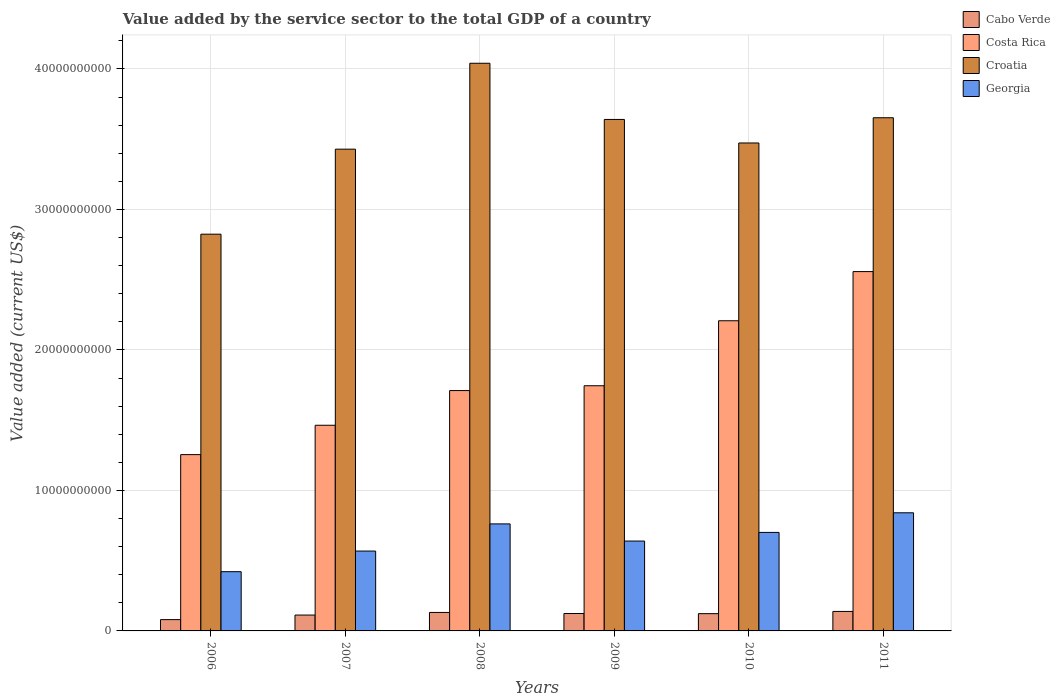How many groups of bars are there?
Provide a succinct answer. 6. Are the number of bars per tick equal to the number of legend labels?
Keep it short and to the point. Yes. Are the number of bars on each tick of the X-axis equal?
Provide a succinct answer. Yes. How many bars are there on the 3rd tick from the left?
Your response must be concise. 4. How many bars are there on the 5th tick from the right?
Your response must be concise. 4. In how many cases, is the number of bars for a given year not equal to the number of legend labels?
Give a very brief answer. 0. What is the value added by the service sector to the total GDP in Georgia in 2011?
Your response must be concise. 8.41e+09. Across all years, what is the maximum value added by the service sector to the total GDP in Georgia?
Ensure brevity in your answer.  8.41e+09. Across all years, what is the minimum value added by the service sector to the total GDP in Costa Rica?
Make the answer very short. 1.25e+1. In which year was the value added by the service sector to the total GDP in Croatia maximum?
Give a very brief answer. 2008. In which year was the value added by the service sector to the total GDP in Costa Rica minimum?
Your answer should be very brief. 2006. What is the total value added by the service sector to the total GDP in Costa Rica in the graph?
Your response must be concise. 1.09e+11. What is the difference between the value added by the service sector to the total GDP in Costa Rica in 2009 and that in 2010?
Provide a succinct answer. -4.63e+09. What is the difference between the value added by the service sector to the total GDP in Croatia in 2010 and the value added by the service sector to the total GDP in Cabo Verde in 2009?
Provide a short and direct response. 3.35e+1. What is the average value added by the service sector to the total GDP in Georgia per year?
Offer a very short reply. 6.56e+09. In the year 2007, what is the difference between the value added by the service sector to the total GDP in Costa Rica and value added by the service sector to the total GDP in Croatia?
Give a very brief answer. -1.97e+1. In how many years, is the value added by the service sector to the total GDP in Costa Rica greater than 32000000000 US$?
Your response must be concise. 0. What is the ratio of the value added by the service sector to the total GDP in Georgia in 2009 to that in 2011?
Give a very brief answer. 0.76. Is the value added by the service sector to the total GDP in Cabo Verde in 2008 less than that in 2009?
Your answer should be very brief. No. Is the difference between the value added by the service sector to the total GDP in Costa Rica in 2009 and 2011 greater than the difference between the value added by the service sector to the total GDP in Croatia in 2009 and 2011?
Give a very brief answer. No. What is the difference between the highest and the second highest value added by the service sector to the total GDP in Cabo Verde?
Keep it short and to the point. 7.23e+07. What is the difference between the highest and the lowest value added by the service sector to the total GDP in Cabo Verde?
Provide a succinct answer. 5.83e+08. What does the 1st bar from the left in 2006 represents?
Your answer should be very brief. Cabo Verde. What does the 4th bar from the right in 2010 represents?
Your answer should be compact. Cabo Verde. How many bars are there?
Make the answer very short. 24. How many years are there in the graph?
Provide a succinct answer. 6. Are the values on the major ticks of Y-axis written in scientific E-notation?
Offer a very short reply. No. Does the graph contain any zero values?
Ensure brevity in your answer.  No. Where does the legend appear in the graph?
Make the answer very short. Top right. How many legend labels are there?
Your answer should be very brief. 4. What is the title of the graph?
Your answer should be very brief. Value added by the service sector to the total GDP of a country. What is the label or title of the Y-axis?
Offer a very short reply. Value added (current US$). What is the Value added (current US$) in Cabo Verde in 2006?
Provide a succinct answer. 8.04e+08. What is the Value added (current US$) of Costa Rica in 2006?
Keep it short and to the point. 1.25e+1. What is the Value added (current US$) of Croatia in 2006?
Make the answer very short. 2.82e+1. What is the Value added (current US$) of Georgia in 2006?
Provide a short and direct response. 4.22e+09. What is the Value added (current US$) of Cabo Verde in 2007?
Offer a terse response. 1.13e+09. What is the Value added (current US$) in Costa Rica in 2007?
Ensure brevity in your answer.  1.46e+1. What is the Value added (current US$) in Croatia in 2007?
Offer a terse response. 3.43e+1. What is the Value added (current US$) of Georgia in 2007?
Ensure brevity in your answer.  5.68e+09. What is the Value added (current US$) in Cabo Verde in 2008?
Give a very brief answer. 1.31e+09. What is the Value added (current US$) in Costa Rica in 2008?
Make the answer very short. 1.71e+1. What is the Value added (current US$) in Croatia in 2008?
Give a very brief answer. 4.04e+1. What is the Value added (current US$) of Georgia in 2008?
Keep it short and to the point. 7.62e+09. What is the Value added (current US$) of Cabo Verde in 2009?
Provide a short and direct response. 1.24e+09. What is the Value added (current US$) of Costa Rica in 2009?
Keep it short and to the point. 1.75e+1. What is the Value added (current US$) in Croatia in 2009?
Provide a short and direct response. 3.64e+1. What is the Value added (current US$) of Georgia in 2009?
Offer a very short reply. 6.40e+09. What is the Value added (current US$) of Cabo Verde in 2010?
Your answer should be very brief. 1.23e+09. What is the Value added (current US$) of Costa Rica in 2010?
Make the answer very short. 2.21e+1. What is the Value added (current US$) of Croatia in 2010?
Your answer should be very brief. 3.47e+1. What is the Value added (current US$) of Georgia in 2010?
Provide a short and direct response. 7.01e+09. What is the Value added (current US$) of Cabo Verde in 2011?
Offer a very short reply. 1.39e+09. What is the Value added (current US$) of Costa Rica in 2011?
Keep it short and to the point. 2.56e+1. What is the Value added (current US$) of Croatia in 2011?
Ensure brevity in your answer.  3.65e+1. What is the Value added (current US$) of Georgia in 2011?
Your response must be concise. 8.41e+09. Across all years, what is the maximum Value added (current US$) of Cabo Verde?
Keep it short and to the point. 1.39e+09. Across all years, what is the maximum Value added (current US$) of Costa Rica?
Ensure brevity in your answer.  2.56e+1. Across all years, what is the maximum Value added (current US$) of Croatia?
Your answer should be compact. 4.04e+1. Across all years, what is the maximum Value added (current US$) in Georgia?
Offer a terse response. 8.41e+09. Across all years, what is the minimum Value added (current US$) in Cabo Verde?
Ensure brevity in your answer.  8.04e+08. Across all years, what is the minimum Value added (current US$) of Costa Rica?
Keep it short and to the point. 1.25e+1. Across all years, what is the minimum Value added (current US$) of Croatia?
Provide a succinct answer. 2.82e+1. Across all years, what is the minimum Value added (current US$) in Georgia?
Give a very brief answer. 4.22e+09. What is the total Value added (current US$) in Cabo Verde in the graph?
Ensure brevity in your answer.  7.10e+09. What is the total Value added (current US$) in Costa Rica in the graph?
Keep it short and to the point. 1.09e+11. What is the total Value added (current US$) of Croatia in the graph?
Give a very brief answer. 2.11e+11. What is the total Value added (current US$) of Georgia in the graph?
Offer a very short reply. 3.93e+1. What is the difference between the Value added (current US$) in Cabo Verde in 2006 and that in 2007?
Your answer should be very brief. -3.25e+08. What is the difference between the Value added (current US$) in Costa Rica in 2006 and that in 2007?
Provide a short and direct response. -2.09e+09. What is the difference between the Value added (current US$) in Croatia in 2006 and that in 2007?
Offer a very short reply. -6.05e+09. What is the difference between the Value added (current US$) of Georgia in 2006 and that in 2007?
Provide a succinct answer. -1.47e+09. What is the difference between the Value added (current US$) in Cabo Verde in 2006 and that in 2008?
Ensure brevity in your answer.  -5.11e+08. What is the difference between the Value added (current US$) of Costa Rica in 2006 and that in 2008?
Your response must be concise. -4.56e+09. What is the difference between the Value added (current US$) in Croatia in 2006 and that in 2008?
Ensure brevity in your answer.  -1.22e+1. What is the difference between the Value added (current US$) of Georgia in 2006 and that in 2008?
Provide a short and direct response. -3.40e+09. What is the difference between the Value added (current US$) in Cabo Verde in 2006 and that in 2009?
Your response must be concise. -4.35e+08. What is the difference between the Value added (current US$) of Costa Rica in 2006 and that in 2009?
Provide a short and direct response. -4.90e+09. What is the difference between the Value added (current US$) of Croatia in 2006 and that in 2009?
Keep it short and to the point. -8.17e+09. What is the difference between the Value added (current US$) in Georgia in 2006 and that in 2009?
Keep it short and to the point. -2.18e+09. What is the difference between the Value added (current US$) of Cabo Verde in 2006 and that in 2010?
Make the answer very short. -4.25e+08. What is the difference between the Value added (current US$) in Costa Rica in 2006 and that in 2010?
Keep it short and to the point. -9.53e+09. What is the difference between the Value added (current US$) in Croatia in 2006 and that in 2010?
Keep it short and to the point. -6.49e+09. What is the difference between the Value added (current US$) of Georgia in 2006 and that in 2010?
Your answer should be very brief. -2.79e+09. What is the difference between the Value added (current US$) of Cabo Verde in 2006 and that in 2011?
Provide a succinct answer. -5.83e+08. What is the difference between the Value added (current US$) in Costa Rica in 2006 and that in 2011?
Provide a short and direct response. -1.30e+1. What is the difference between the Value added (current US$) of Croatia in 2006 and that in 2011?
Offer a terse response. -8.29e+09. What is the difference between the Value added (current US$) in Georgia in 2006 and that in 2011?
Make the answer very short. -4.19e+09. What is the difference between the Value added (current US$) in Cabo Verde in 2007 and that in 2008?
Keep it short and to the point. -1.86e+08. What is the difference between the Value added (current US$) of Costa Rica in 2007 and that in 2008?
Give a very brief answer. -2.47e+09. What is the difference between the Value added (current US$) of Croatia in 2007 and that in 2008?
Your response must be concise. -6.11e+09. What is the difference between the Value added (current US$) of Georgia in 2007 and that in 2008?
Keep it short and to the point. -1.93e+09. What is the difference between the Value added (current US$) of Cabo Verde in 2007 and that in 2009?
Give a very brief answer. -1.11e+08. What is the difference between the Value added (current US$) in Costa Rica in 2007 and that in 2009?
Offer a terse response. -2.81e+09. What is the difference between the Value added (current US$) of Croatia in 2007 and that in 2009?
Provide a short and direct response. -2.12e+09. What is the difference between the Value added (current US$) in Georgia in 2007 and that in 2009?
Keep it short and to the point. -7.12e+08. What is the difference between the Value added (current US$) in Cabo Verde in 2007 and that in 2010?
Give a very brief answer. -1.00e+08. What is the difference between the Value added (current US$) in Costa Rica in 2007 and that in 2010?
Your answer should be compact. -7.44e+09. What is the difference between the Value added (current US$) in Croatia in 2007 and that in 2010?
Make the answer very short. -4.40e+08. What is the difference between the Value added (current US$) in Georgia in 2007 and that in 2010?
Give a very brief answer. -1.33e+09. What is the difference between the Value added (current US$) of Cabo Verde in 2007 and that in 2011?
Make the answer very short. -2.58e+08. What is the difference between the Value added (current US$) of Costa Rica in 2007 and that in 2011?
Give a very brief answer. -1.09e+1. What is the difference between the Value added (current US$) in Croatia in 2007 and that in 2011?
Your answer should be very brief. -2.24e+09. What is the difference between the Value added (current US$) of Georgia in 2007 and that in 2011?
Ensure brevity in your answer.  -2.72e+09. What is the difference between the Value added (current US$) in Cabo Verde in 2008 and that in 2009?
Your answer should be compact. 7.53e+07. What is the difference between the Value added (current US$) in Costa Rica in 2008 and that in 2009?
Ensure brevity in your answer.  -3.43e+08. What is the difference between the Value added (current US$) of Croatia in 2008 and that in 2009?
Your response must be concise. 4.00e+09. What is the difference between the Value added (current US$) in Georgia in 2008 and that in 2009?
Provide a succinct answer. 1.22e+09. What is the difference between the Value added (current US$) in Cabo Verde in 2008 and that in 2010?
Your answer should be very brief. 8.57e+07. What is the difference between the Value added (current US$) of Costa Rica in 2008 and that in 2010?
Give a very brief answer. -4.97e+09. What is the difference between the Value added (current US$) in Croatia in 2008 and that in 2010?
Offer a terse response. 5.67e+09. What is the difference between the Value added (current US$) of Georgia in 2008 and that in 2010?
Give a very brief answer. 6.06e+08. What is the difference between the Value added (current US$) in Cabo Verde in 2008 and that in 2011?
Your response must be concise. -7.23e+07. What is the difference between the Value added (current US$) in Costa Rica in 2008 and that in 2011?
Provide a short and direct response. -8.47e+09. What is the difference between the Value added (current US$) of Croatia in 2008 and that in 2011?
Provide a succinct answer. 3.88e+09. What is the difference between the Value added (current US$) in Georgia in 2008 and that in 2011?
Make the answer very short. -7.90e+08. What is the difference between the Value added (current US$) in Cabo Verde in 2009 and that in 2010?
Give a very brief answer. 1.04e+07. What is the difference between the Value added (current US$) in Costa Rica in 2009 and that in 2010?
Offer a terse response. -4.63e+09. What is the difference between the Value added (current US$) in Croatia in 2009 and that in 2010?
Offer a terse response. 1.67e+09. What is the difference between the Value added (current US$) of Georgia in 2009 and that in 2010?
Make the answer very short. -6.16e+08. What is the difference between the Value added (current US$) in Cabo Verde in 2009 and that in 2011?
Your response must be concise. -1.48e+08. What is the difference between the Value added (current US$) in Costa Rica in 2009 and that in 2011?
Your answer should be very brief. -8.13e+09. What is the difference between the Value added (current US$) in Croatia in 2009 and that in 2011?
Provide a short and direct response. -1.21e+08. What is the difference between the Value added (current US$) of Georgia in 2009 and that in 2011?
Provide a short and direct response. -2.01e+09. What is the difference between the Value added (current US$) of Cabo Verde in 2010 and that in 2011?
Provide a short and direct response. -1.58e+08. What is the difference between the Value added (current US$) in Costa Rica in 2010 and that in 2011?
Offer a terse response. -3.50e+09. What is the difference between the Value added (current US$) of Croatia in 2010 and that in 2011?
Provide a succinct answer. -1.80e+09. What is the difference between the Value added (current US$) in Georgia in 2010 and that in 2011?
Offer a very short reply. -1.40e+09. What is the difference between the Value added (current US$) of Cabo Verde in 2006 and the Value added (current US$) of Costa Rica in 2007?
Offer a terse response. -1.38e+1. What is the difference between the Value added (current US$) in Cabo Verde in 2006 and the Value added (current US$) in Croatia in 2007?
Ensure brevity in your answer.  -3.35e+1. What is the difference between the Value added (current US$) in Cabo Verde in 2006 and the Value added (current US$) in Georgia in 2007?
Your answer should be compact. -4.88e+09. What is the difference between the Value added (current US$) of Costa Rica in 2006 and the Value added (current US$) of Croatia in 2007?
Provide a succinct answer. -2.17e+1. What is the difference between the Value added (current US$) in Costa Rica in 2006 and the Value added (current US$) in Georgia in 2007?
Make the answer very short. 6.86e+09. What is the difference between the Value added (current US$) of Croatia in 2006 and the Value added (current US$) of Georgia in 2007?
Make the answer very short. 2.26e+1. What is the difference between the Value added (current US$) in Cabo Verde in 2006 and the Value added (current US$) in Costa Rica in 2008?
Your answer should be very brief. -1.63e+1. What is the difference between the Value added (current US$) in Cabo Verde in 2006 and the Value added (current US$) in Croatia in 2008?
Provide a succinct answer. -3.96e+1. What is the difference between the Value added (current US$) of Cabo Verde in 2006 and the Value added (current US$) of Georgia in 2008?
Keep it short and to the point. -6.81e+09. What is the difference between the Value added (current US$) of Costa Rica in 2006 and the Value added (current US$) of Croatia in 2008?
Your answer should be very brief. -2.79e+1. What is the difference between the Value added (current US$) in Costa Rica in 2006 and the Value added (current US$) in Georgia in 2008?
Offer a very short reply. 4.93e+09. What is the difference between the Value added (current US$) of Croatia in 2006 and the Value added (current US$) of Georgia in 2008?
Give a very brief answer. 2.06e+1. What is the difference between the Value added (current US$) of Cabo Verde in 2006 and the Value added (current US$) of Costa Rica in 2009?
Your response must be concise. -1.66e+1. What is the difference between the Value added (current US$) of Cabo Verde in 2006 and the Value added (current US$) of Croatia in 2009?
Provide a succinct answer. -3.56e+1. What is the difference between the Value added (current US$) in Cabo Verde in 2006 and the Value added (current US$) in Georgia in 2009?
Ensure brevity in your answer.  -5.59e+09. What is the difference between the Value added (current US$) of Costa Rica in 2006 and the Value added (current US$) of Croatia in 2009?
Your response must be concise. -2.39e+1. What is the difference between the Value added (current US$) in Costa Rica in 2006 and the Value added (current US$) in Georgia in 2009?
Keep it short and to the point. 6.15e+09. What is the difference between the Value added (current US$) in Croatia in 2006 and the Value added (current US$) in Georgia in 2009?
Ensure brevity in your answer.  2.18e+1. What is the difference between the Value added (current US$) of Cabo Verde in 2006 and the Value added (current US$) of Costa Rica in 2010?
Give a very brief answer. -2.13e+1. What is the difference between the Value added (current US$) of Cabo Verde in 2006 and the Value added (current US$) of Croatia in 2010?
Give a very brief answer. -3.39e+1. What is the difference between the Value added (current US$) of Cabo Verde in 2006 and the Value added (current US$) of Georgia in 2010?
Offer a very short reply. -6.21e+09. What is the difference between the Value added (current US$) in Costa Rica in 2006 and the Value added (current US$) in Croatia in 2010?
Your response must be concise. -2.22e+1. What is the difference between the Value added (current US$) in Costa Rica in 2006 and the Value added (current US$) in Georgia in 2010?
Your answer should be compact. 5.54e+09. What is the difference between the Value added (current US$) in Croatia in 2006 and the Value added (current US$) in Georgia in 2010?
Offer a very short reply. 2.12e+1. What is the difference between the Value added (current US$) in Cabo Verde in 2006 and the Value added (current US$) in Costa Rica in 2011?
Offer a terse response. -2.48e+1. What is the difference between the Value added (current US$) of Cabo Verde in 2006 and the Value added (current US$) of Croatia in 2011?
Provide a short and direct response. -3.57e+1. What is the difference between the Value added (current US$) of Cabo Verde in 2006 and the Value added (current US$) of Georgia in 2011?
Your answer should be very brief. -7.60e+09. What is the difference between the Value added (current US$) in Costa Rica in 2006 and the Value added (current US$) in Croatia in 2011?
Provide a short and direct response. -2.40e+1. What is the difference between the Value added (current US$) of Costa Rica in 2006 and the Value added (current US$) of Georgia in 2011?
Offer a terse response. 4.14e+09. What is the difference between the Value added (current US$) in Croatia in 2006 and the Value added (current US$) in Georgia in 2011?
Your answer should be compact. 1.98e+1. What is the difference between the Value added (current US$) of Cabo Verde in 2007 and the Value added (current US$) of Costa Rica in 2008?
Your response must be concise. -1.60e+1. What is the difference between the Value added (current US$) of Cabo Verde in 2007 and the Value added (current US$) of Croatia in 2008?
Offer a very short reply. -3.93e+1. What is the difference between the Value added (current US$) of Cabo Verde in 2007 and the Value added (current US$) of Georgia in 2008?
Offer a terse response. -6.49e+09. What is the difference between the Value added (current US$) of Costa Rica in 2007 and the Value added (current US$) of Croatia in 2008?
Your answer should be very brief. -2.58e+1. What is the difference between the Value added (current US$) in Costa Rica in 2007 and the Value added (current US$) in Georgia in 2008?
Give a very brief answer. 7.02e+09. What is the difference between the Value added (current US$) in Croatia in 2007 and the Value added (current US$) in Georgia in 2008?
Your answer should be very brief. 2.67e+1. What is the difference between the Value added (current US$) in Cabo Verde in 2007 and the Value added (current US$) in Costa Rica in 2009?
Offer a terse response. -1.63e+1. What is the difference between the Value added (current US$) in Cabo Verde in 2007 and the Value added (current US$) in Croatia in 2009?
Give a very brief answer. -3.53e+1. What is the difference between the Value added (current US$) in Cabo Verde in 2007 and the Value added (current US$) in Georgia in 2009?
Keep it short and to the point. -5.27e+09. What is the difference between the Value added (current US$) in Costa Rica in 2007 and the Value added (current US$) in Croatia in 2009?
Offer a terse response. -2.18e+1. What is the difference between the Value added (current US$) in Costa Rica in 2007 and the Value added (current US$) in Georgia in 2009?
Provide a short and direct response. 8.24e+09. What is the difference between the Value added (current US$) of Croatia in 2007 and the Value added (current US$) of Georgia in 2009?
Offer a terse response. 2.79e+1. What is the difference between the Value added (current US$) in Cabo Verde in 2007 and the Value added (current US$) in Costa Rica in 2010?
Offer a very short reply. -2.09e+1. What is the difference between the Value added (current US$) of Cabo Verde in 2007 and the Value added (current US$) of Croatia in 2010?
Ensure brevity in your answer.  -3.36e+1. What is the difference between the Value added (current US$) in Cabo Verde in 2007 and the Value added (current US$) in Georgia in 2010?
Your answer should be compact. -5.88e+09. What is the difference between the Value added (current US$) in Costa Rica in 2007 and the Value added (current US$) in Croatia in 2010?
Give a very brief answer. -2.01e+1. What is the difference between the Value added (current US$) of Costa Rica in 2007 and the Value added (current US$) of Georgia in 2010?
Ensure brevity in your answer.  7.63e+09. What is the difference between the Value added (current US$) in Croatia in 2007 and the Value added (current US$) in Georgia in 2010?
Make the answer very short. 2.73e+1. What is the difference between the Value added (current US$) in Cabo Verde in 2007 and the Value added (current US$) in Costa Rica in 2011?
Provide a short and direct response. -2.44e+1. What is the difference between the Value added (current US$) of Cabo Verde in 2007 and the Value added (current US$) of Croatia in 2011?
Provide a succinct answer. -3.54e+1. What is the difference between the Value added (current US$) in Cabo Verde in 2007 and the Value added (current US$) in Georgia in 2011?
Provide a succinct answer. -7.28e+09. What is the difference between the Value added (current US$) in Costa Rica in 2007 and the Value added (current US$) in Croatia in 2011?
Offer a very short reply. -2.19e+1. What is the difference between the Value added (current US$) in Costa Rica in 2007 and the Value added (current US$) in Georgia in 2011?
Offer a terse response. 6.23e+09. What is the difference between the Value added (current US$) in Croatia in 2007 and the Value added (current US$) in Georgia in 2011?
Give a very brief answer. 2.59e+1. What is the difference between the Value added (current US$) in Cabo Verde in 2008 and the Value added (current US$) in Costa Rica in 2009?
Your answer should be compact. -1.61e+1. What is the difference between the Value added (current US$) of Cabo Verde in 2008 and the Value added (current US$) of Croatia in 2009?
Your answer should be compact. -3.51e+1. What is the difference between the Value added (current US$) of Cabo Verde in 2008 and the Value added (current US$) of Georgia in 2009?
Provide a succinct answer. -5.08e+09. What is the difference between the Value added (current US$) of Costa Rica in 2008 and the Value added (current US$) of Croatia in 2009?
Your response must be concise. -1.93e+1. What is the difference between the Value added (current US$) in Costa Rica in 2008 and the Value added (current US$) in Georgia in 2009?
Give a very brief answer. 1.07e+1. What is the difference between the Value added (current US$) of Croatia in 2008 and the Value added (current US$) of Georgia in 2009?
Your answer should be very brief. 3.40e+1. What is the difference between the Value added (current US$) of Cabo Verde in 2008 and the Value added (current US$) of Costa Rica in 2010?
Your response must be concise. -2.08e+1. What is the difference between the Value added (current US$) of Cabo Verde in 2008 and the Value added (current US$) of Croatia in 2010?
Your answer should be very brief. -3.34e+1. What is the difference between the Value added (current US$) of Cabo Verde in 2008 and the Value added (current US$) of Georgia in 2010?
Provide a short and direct response. -5.70e+09. What is the difference between the Value added (current US$) of Costa Rica in 2008 and the Value added (current US$) of Croatia in 2010?
Make the answer very short. -1.76e+1. What is the difference between the Value added (current US$) of Costa Rica in 2008 and the Value added (current US$) of Georgia in 2010?
Give a very brief answer. 1.01e+1. What is the difference between the Value added (current US$) in Croatia in 2008 and the Value added (current US$) in Georgia in 2010?
Offer a very short reply. 3.34e+1. What is the difference between the Value added (current US$) of Cabo Verde in 2008 and the Value added (current US$) of Costa Rica in 2011?
Keep it short and to the point. -2.43e+1. What is the difference between the Value added (current US$) of Cabo Verde in 2008 and the Value added (current US$) of Croatia in 2011?
Offer a terse response. -3.52e+1. What is the difference between the Value added (current US$) of Cabo Verde in 2008 and the Value added (current US$) of Georgia in 2011?
Make the answer very short. -7.09e+09. What is the difference between the Value added (current US$) of Costa Rica in 2008 and the Value added (current US$) of Croatia in 2011?
Offer a terse response. -1.94e+1. What is the difference between the Value added (current US$) of Costa Rica in 2008 and the Value added (current US$) of Georgia in 2011?
Keep it short and to the point. 8.70e+09. What is the difference between the Value added (current US$) of Croatia in 2008 and the Value added (current US$) of Georgia in 2011?
Provide a short and direct response. 3.20e+1. What is the difference between the Value added (current US$) of Cabo Verde in 2009 and the Value added (current US$) of Costa Rica in 2010?
Make the answer very short. -2.08e+1. What is the difference between the Value added (current US$) in Cabo Verde in 2009 and the Value added (current US$) in Croatia in 2010?
Offer a very short reply. -3.35e+1. What is the difference between the Value added (current US$) of Cabo Verde in 2009 and the Value added (current US$) of Georgia in 2010?
Your response must be concise. -5.77e+09. What is the difference between the Value added (current US$) in Costa Rica in 2009 and the Value added (current US$) in Croatia in 2010?
Offer a very short reply. -1.73e+1. What is the difference between the Value added (current US$) in Costa Rica in 2009 and the Value added (current US$) in Georgia in 2010?
Your response must be concise. 1.04e+1. What is the difference between the Value added (current US$) in Croatia in 2009 and the Value added (current US$) in Georgia in 2010?
Provide a succinct answer. 2.94e+1. What is the difference between the Value added (current US$) in Cabo Verde in 2009 and the Value added (current US$) in Costa Rica in 2011?
Provide a succinct answer. -2.43e+1. What is the difference between the Value added (current US$) of Cabo Verde in 2009 and the Value added (current US$) of Croatia in 2011?
Provide a short and direct response. -3.53e+1. What is the difference between the Value added (current US$) of Cabo Verde in 2009 and the Value added (current US$) of Georgia in 2011?
Give a very brief answer. -7.17e+09. What is the difference between the Value added (current US$) of Costa Rica in 2009 and the Value added (current US$) of Croatia in 2011?
Your answer should be very brief. -1.91e+1. What is the difference between the Value added (current US$) of Costa Rica in 2009 and the Value added (current US$) of Georgia in 2011?
Your response must be concise. 9.04e+09. What is the difference between the Value added (current US$) in Croatia in 2009 and the Value added (current US$) in Georgia in 2011?
Make the answer very short. 2.80e+1. What is the difference between the Value added (current US$) of Cabo Verde in 2010 and the Value added (current US$) of Costa Rica in 2011?
Give a very brief answer. -2.43e+1. What is the difference between the Value added (current US$) of Cabo Verde in 2010 and the Value added (current US$) of Croatia in 2011?
Keep it short and to the point. -3.53e+1. What is the difference between the Value added (current US$) of Cabo Verde in 2010 and the Value added (current US$) of Georgia in 2011?
Make the answer very short. -7.18e+09. What is the difference between the Value added (current US$) in Costa Rica in 2010 and the Value added (current US$) in Croatia in 2011?
Your answer should be compact. -1.45e+1. What is the difference between the Value added (current US$) of Costa Rica in 2010 and the Value added (current US$) of Georgia in 2011?
Make the answer very short. 1.37e+1. What is the difference between the Value added (current US$) of Croatia in 2010 and the Value added (current US$) of Georgia in 2011?
Offer a very short reply. 2.63e+1. What is the average Value added (current US$) of Cabo Verde per year?
Offer a very short reply. 1.18e+09. What is the average Value added (current US$) of Costa Rica per year?
Your answer should be very brief. 1.82e+1. What is the average Value added (current US$) of Croatia per year?
Your response must be concise. 3.51e+1. What is the average Value added (current US$) in Georgia per year?
Provide a succinct answer. 6.56e+09. In the year 2006, what is the difference between the Value added (current US$) in Cabo Verde and Value added (current US$) in Costa Rica?
Provide a short and direct response. -1.17e+1. In the year 2006, what is the difference between the Value added (current US$) of Cabo Verde and Value added (current US$) of Croatia?
Offer a very short reply. -2.74e+1. In the year 2006, what is the difference between the Value added (current US$) of Cabo Verde and Value added (current US$) of Georgia?
Your answer should be compact. -3.41e+09. In the year 2006, what is the difference between the Value added (current US$) in Costa Rica and Value added (current US$) in Croatia?
Ensure brevity in your answer.  -1.57e+1. In the year 2006, what is the difference between the Value added (current US$) in Costa Rica and Value added (current US$) in Georgia?
Your response must be concise. 8.33e+09. In the year 2006, what is the difference between the Value added (current US$) in Croatia and Value added (current US$) in Georgia?
Your answer should be compact. 2.40e+1. In the year 2007, what is the difference between the Value added (current US$) of Cabo Verde and Value added (current US$) of Costa Rica?
Ensure brevity in your answer.  -1.35e+1. In the year 2007, what is the difference between the Value added (current US$) of Cabo Verde and Value added (current US$) of Croatia?
Give a very brief answer. -3.32e+1. In the year 2007, what is the difference between the Value added (current US$) in Cabo Verde and Value added (current US$) in Georgia?
Keep it short and to the point. -4.56e+09. In the year 2007, what is the difference between the Value added (current US$) in Costa Rica and Value added (current US$) in Croatia?
Offer a terse response. -1.97e+1. In the year 2007, what is the difference between the Value added (current US$) in Costa Rica and Value added (current US$) in Georgia?
Keep it short and to the point. 8.95e+09. In the year 2007, what is the difference between the Value added (current US$) in Croatia and Value added (current US$) in Georgia?
Give a very brief answer. 2.86e+1. In the year 2008, what is the difference between the Value added (current US$) in Cabo Verde and Value added (current US$) in Costa Rica?
Offer a terse response. -1.58e+1. In the year 2008, what is the difference between the Value added (current US$) in Cabo Verde and Value added (current US$) in Croatia?
Provide a succinct answer. -3.91e+1. In the year 2008, what is the difference between the Value added (current US$) of Cabo Verde and Value added (current US$) of Georgia?
Your answer should be compact. -6.30e+09. In the year 2008, what is the difference between the Value added (current US$) in Costa Rica and Value added (current US$) in Croatia?
Your response must be concise. -2.33e+1. In the year 2008, what is the difference between the Value added (current US$) in Costa Rica and Value added (current US$) in Georgia?
Keep it short and to the point. 9.49e+09. In the year 2008, what is the difference between the Value added (current US$) of Croatia and Value added (current US$) of Georgia?
Offer a terse response. 3.28e+1. In the year 2009, what is the difference between the Value added (current US$) of Cabo Verde and Value added (current US$) of Costa Rica?
Your response must be concise. -1.62e+1. In the year 2009, what is the difference between the Value added (current US$) in Cabo Verde and Value added (current US$) in Croatia?
Provide a short and direct response. -3.52e+1. In the year 2009, what is the difference between the Value added (current US$) in Cabo Verde and Value added (current US$) in Georgia?
Provide a short and direct response. -5.16e+09. In the year 2009, what is the difference between the Value added (current US$) in Costa Rica and Value added (current US$) in Croatia?
Offer a very short reply. -1.90e+1. In the year 2009, what is the difference between the Value added (current US$) in Costa Rica and Value added (current US$) in Georgia?
Your response must be concise. 1.11e+1. In the year 2009, what is the difference between the Value added (current US$) of Croatia and Value added (current US$) of Georgia?
Provide a succinct answer. 3.00e+1. In the year 2010, what is the difference between the Value added (current US$) in Cabo Verde and Value added (current US$) in Costa Rica?
Offer a terse response. -2.08e+1. In the year 2010, what is the difference between the Value added (current US$) of Cabo Verde and Value added (current US$) of Croatia?
Your answer should be compact. -3.35e+1. In the year 2010, what is the difference between the Value added (current US$) of Cabo Verde and Value added (current US$) of Georgia?
Make the answer very short. -5.78e+09. In the year 2010, what is the difference between the Value added (current US$) of Costa Rica and Value added (current US$) of Croatia?
Provide a succinct answer. -1.27e+1. In the year 2010, what is the difference between the Value added (current US$) in Costa Rica and Value added (current US$) in Georgia?
Provide a short and direct response. 1.51e+1. In the year 2010, what is the difference between the Value added (current US$) in Croatia and Value added (current US$) in Georgia?
Your answer should be compact. 2.77e+1. In the year 2011, what is the difference between the Value added (current US$) of Cabo Verde and Value added (current US$) of Costa Rica?
Your answer should be compact. -2.42e+1. In the year 2011, what is the difference between the Value added (current US$) of Cabo Verde and Value added (current US$) of Croatia?
Give a very brief answer. -3.51e+1. In the year 2011, what is the difference between the Value added (current US$) in Cabo Verde and Value added (current US$) in Georgia?
Provide a short and direct response. -7.02e+09. In the year 2011, what is the difference between the Value added (current US$) in Costa Rica and Value added (current US$) in Croatia?
Ensure brevity in your answer.  -1.10e+1. In the year 2011, what is the difference between the Value added (current US$) in Costa Rica and Value added (current US$) in Georgia?
Offer a very short reply. 1.72e+1. In the year 2011, what is the difference between the Value added (current US$) in Croatia and Value added (current US$) in Georgia?
Offer a terse response. 2.81e+1. What is the ratio of the Value added (current US$) in Cabo Verde in 2006 to that in 2007?
Your answer should be very brief. 0.71. What is the ratio of the Value added (current US$) in Costa Rica in 2006 to that in 2007?
Give a very brief answer. 0.86. What is the ratio of the Value added (current US$) in Croatia in 2006 to that in 2007?
Give a very brief answer. 0.82. What is the ratio of the Value added (current US$) in Georgia in 2006 to that in 2007?
Give a very brief answer. 0.74. What is the ratio of the Value added (current US$) in Cabo Verde in 2006 to that in 2008?
Offer a terse response. 0.61. What is the ratio of the Value added (current US$) of Costa Rica in 2006 to that in 2008?
Provide a short and direct response. 0.73. What is the ratio of the Value added (current US$) in Croatia in 2006 to that in 2008?
Provide a short and direct response. 0.7. What is the ratio of the Value added (current US$) of Georgia in 2006 to that in 2008?
Your answer should be compact. 0.55. What is the ratio of the Value added (current US$) of Cabo Verde in 2006 to that in 2009?
Give a very brief answer. 0.65. What is the ratio of the Value added (current US$) in Costa Rica in 2006 to that in 2009?
Give a very brief answer. 0.72. What is the ratio of the Value added (current US$) in Croatia in 2006 to that in 2009?
Make the answer very short. 0.78. What is the ratio of the Value added (current US$) in Georgia in 2006 to that in 2009?
Ensure brevity in your answer.  0.66. What is the ratio of the Value added (current US$) in Cabo Verde in 2006 to that in 2010?
Your response must be concise. 0.65. What is the ratio of the Value added (current US$) of Costa Rica in 2006 to that in 2010?
Ensure brevity in your answer.  0.57. What is the ratio of the Value added (current US$) in Croatia in 2006 to that in 2010?
Ensure brevity in your answer.  0.81. What is the ratio of the Value added (current US$) of Georgia in 2006 to that in 2010?
Your answer should be compact. 0.6. What is the ratio of the Value added (current US$) of Cabo Verde in 2006 to that in 2011?
Your answer should be very brief. 0.58. What is the ratio of the Value added (current US$) in Costa Rica in 2006 to that in 2011?
Your answer should be compact. 0.49. What is the ratio of the Value added (current US$) in Croatia in 2006 to that in 2011?
Your answer should be very brief. 0.77. What is the ratio of the Value added (current US$) of Georgia in 2006 to that in 2011?
Ensure brevity in your answer.  0.5. What is the ratio of the Value added (current US$) in Cabo Verde in 2007 to that in 2008?
Your response must be concise. 0.86. What is the ratio of the Value added (current US$) in Costa Rica in 2007 to that in 2008?
Give a very brief answer. 0.86. What is the ratio of the Value added (current US$) of Croatia in 2007 to that in 2008?
Offer a very short reply. 0.85. What is the ratio of the Value added (current US$) of Georgia in 2007 to that in 2008?
Your answer should be compact. 0.75. What is the ratio of the Value added (current US$) in Cabo Verde in 2007 to that in 2009?
Ensure brevity in your answer.  0.91. What is the ratio of the Value added (current US$) of Costa Rica in 2007 to that in 2009?
Your answer should be compact. 0.84. What is the ratio of the Value added (current US$) of Croatia in 2007 to that in 2009?
Offer a terse response. 0.94. What is the ratio of the Value added (current US$) of Georgia in 2007 to that in 2009?
Give a very brief answer. 0.89. What is the ratio of the Value added (current US$) of Cabo Verde in 2007 to that in 2010?
Make the answer very short. 0.92. What is the ratio of the Value added (current US$) in Costa Rica in 2007 to that in 2010?
Your answer should be very brief. 0.66. What is the ratio of the Value added (current US$) in Croatia in 2007 to that in 2010?
Provide a succinct answer. 0.99. What is the ratio of the Value added (current US$) in Georgia in 2007 to that in 2010?
Offer a very short reply. 0.81. What is the ratio of the Value added (current US$) of Cabo Verde in 2007 to that in 2011?
Your response must be concise. 0.81. What is the ratio of the Value added (current US$) in Costa Rica in 2007 to that in 2011?
Keep it short and to the point. 0.57. What is the ratio of the Value added (current US$) in Croatia in 2007 to that in 2011?
Offer a very short reply. 0.94. What is the ratio of the Value added (current US$) in Georgia in 2007 to that in 2011?
Make the answer very short. 0.68. What is the ratio of the Value added (current US$) in Cabo Verde in 2008 to that in 2009?
Provide a short and direct response. 1.06. What is the ratio of the Value added (current US$) in Costa Rica in 2008 to that in 2009?
Make the answer very short. 0.98. What is the ratio of the Value added (current US$) in Croatia in 2008 to that in 2009?
Your response must be concise. 1.11. What is the ratio of the Value added (current US$) in Georgia in 2008 to that in 2009?
Ensure brevity in your answer.  1.19. What is the ratio of the Value added (current US$) in Cabo Verde in 2008 to that in 2010?
Make the answer very short. 1.07. What is the ratio of the Value added (current US$) of Costa Rica in 2008 to that in 2010?
Your answer should be compact. 0.77. What is the ratio of the Value added (current US$) of Croatia in 2008 to that in 2010?
Offer a terse response. 1.16. What is the ratio of the Value added (current US$) of Georgia in 2008 to that in 2010?
Provide a short and direct response. 1.09. What is the ratio of the Value added (current US$) in Cabo Verde in 2008 to that in 2011?
Provide a succinct answer. 0.95. What is the ratio of the Value added (current US$) of Costa Rica in 2008 to that in 2011?
Ensure brevity in your answer.  0.67. What is the ratio of the Value added (current US$) in Croatia in 2008 to that in 2011?
Ensure brevity in your answer.  1.11. What is the ratio of the Value added (current US$) of Georgia in 2008 to that in 2011?
Offer a terse response. 0.91. What is the ratio of the Value added (current US$) in Cabo Verde in 2009 to that in 2010?
Your response must be concise. 1.01. What is the ratio of the Value added (current US$) in Costa Rica in 2009 to that in 2010?
Provide a succinct answer. 0.79. What is the ratio of the Value added (current US$) in Croatia in 2009 to that in 2010?
Provide a short and direct response. 1.05. What is the ratio of the Value added (current US$) in Georgia in 2009 to that in 2010?
Your answer should be very brief. 0.91. What is the ratio of the Value added (current US$) in Cabo Verde in 2009 to that in 2011?
Provide a succinct answer. 0.89. What is the ratio of the Value added (current US$) in Costa Rica in 2009 to that in 2011?
Ensure brevity in your answer.  0.68. What is the ratio of the Value added (current US$) of Croatia in 2009 to that in 2011?
Offer a terse response. 1. What is the ratio of the Value added (current US$) of Georgia in 2009 to that in 2011?
Your answer should be very brief. 0.76. What is the ratio of the Value added (current US$) of Cabo Verde in 2010 to that in 2011?
Keep it short and to the point. 0.89. What is the ratio of the Value added (current US$) in Costa Rica in 2010 to that in 2011?
Your response must be concise. 0.86. What is the ratio of the Value added (current US$) in Croatia in 2010 to that in 2011?
Offer a very short reply. 0.95. What is the ratio of the Value added (current US$) in Georgia in 2010 to that in 2011?
Offer a terse response. 0.83. What is the difference between the highest and the second highest Value added (current US$) of Cabo Verde?
Offer a terse response. 7.23e+07. What is the difference between the highest and the second highest Value added (current US$) in Costa Rica?
Keep it short and to the point. 3.50e+09. What is the difference between the highest and the second highest Value added (current US$) of Croatia?
Offer a terse response. 3.88e+09. What is the difference between the highest and the second highest Value added (current US$) of Georgia?
Offer a very short reply. 7.90e+08. What is the difference between the highest and the lowest Value added (current US$) of Cabo Verde?
Ensure brevity in your answer.  5.83e+08. What is the difference between the highest and the lowest Value added (current US$) of Costa Rica?
Make the answer very short. 1.30e+1. What is the difference between the highest and the lowest Value added (current US$) in Croatia?
Keep it short and to the point. 1.22e+1. What is the difference between the highest and the lowest Value added (current US$) in Georgia?
Offer a terse response. 4.19e+09. 